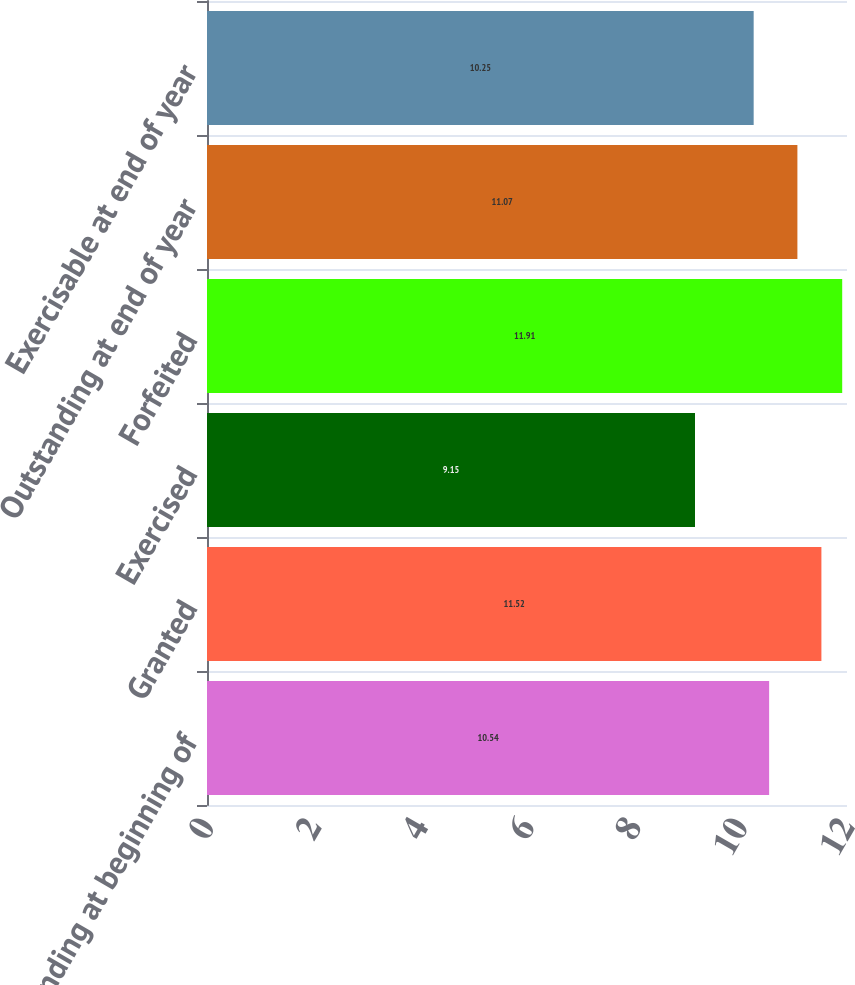<chart> <loc_0><loc_0><loc_500><loc_500><bar_chart><fcel>Outstanding at beginning of<fcel>Granted<fcel>Exercised<fcel>Forfeited<fcel>Outstanding at end of year<fcel>Exercisable at end of year<nl><fcel>10.54<fcel>11.52<fcel>9.15<fcel>11.91<fcel>11.07<fcel>10.25<nl></chart> 